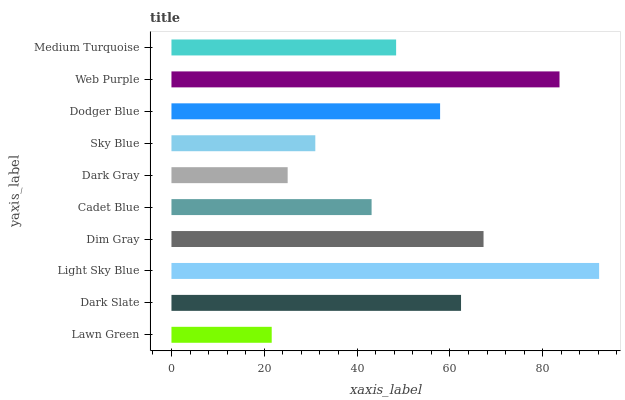Is Lawn Green the minimum?
Answer yes or no. Yes. Is Light Sky Blue the maximum?
Answer yes or no. Yes. Is Dark Slate the minimum?
Answer yes or no. No. Is Dark Slate the maximum?
Answer yes or no. No. Is Dark Slate greater than Lawn Green?
Answer yes or no. Yes. Is Lawn Green less than Dark Slate?
Answer yes or no. Yes. Is Lawn Green greater than Dark Slate?
Answer yes or no. No. Is Dark Slate less than Lawn Green?
Answer yes or no. No. Is Dodger Blue the high median?
Answer yes or no. Yes. Is Medium Turquoise the low median?
Answer yes or no. Yes. Is Dark Gray the high median?
Answer yes or no. No. Is Light Sky Blue the low median?
Answer yes or no. No. 